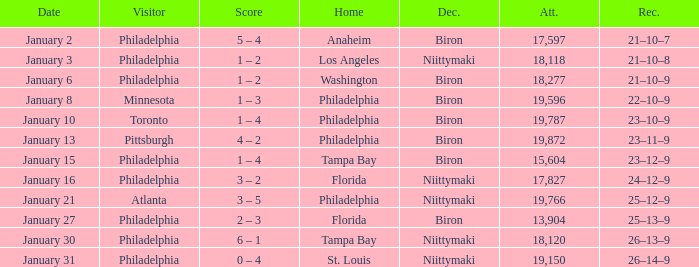What is the decision of the game on January 13? Biron. 